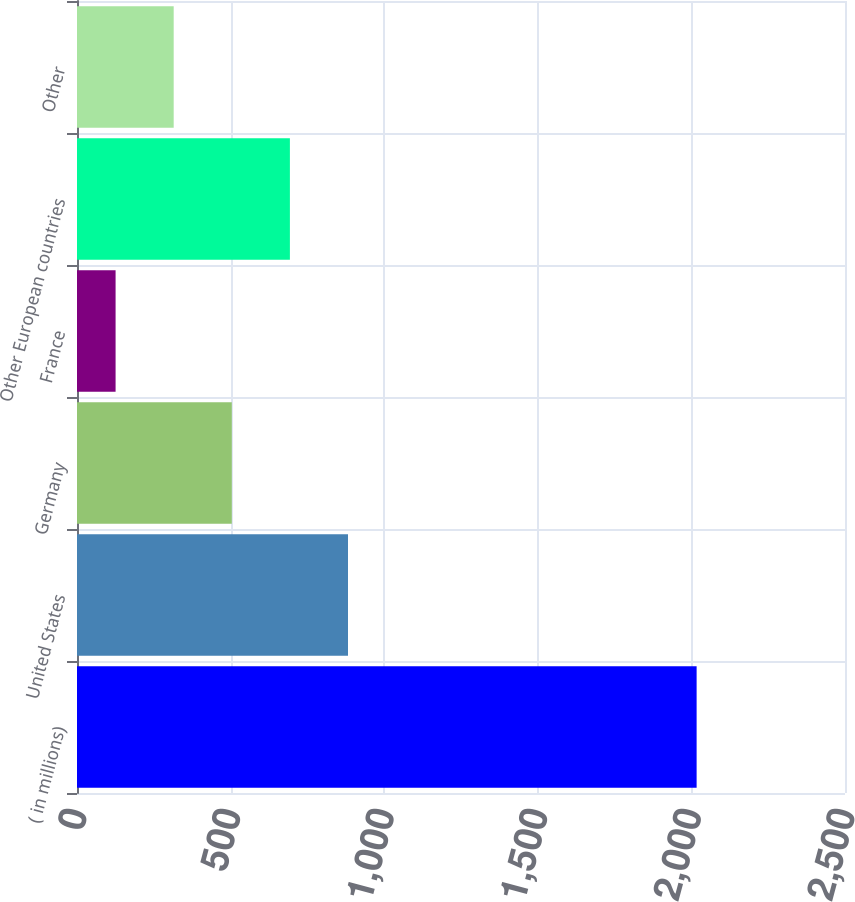Convert chart. <chart><loc_0><loc_0><loc_500><loc_500><bar_chart><fcel>( in millions)<fcel>United States<fcel>Germany<fcel>France<fcel>Other European countries<fcel>Other<nl><fcel>2017<fcel>882.16<fcel>503.88<fcel>125.6<fcel>693.02<fcel>314.74<nl></chart> 